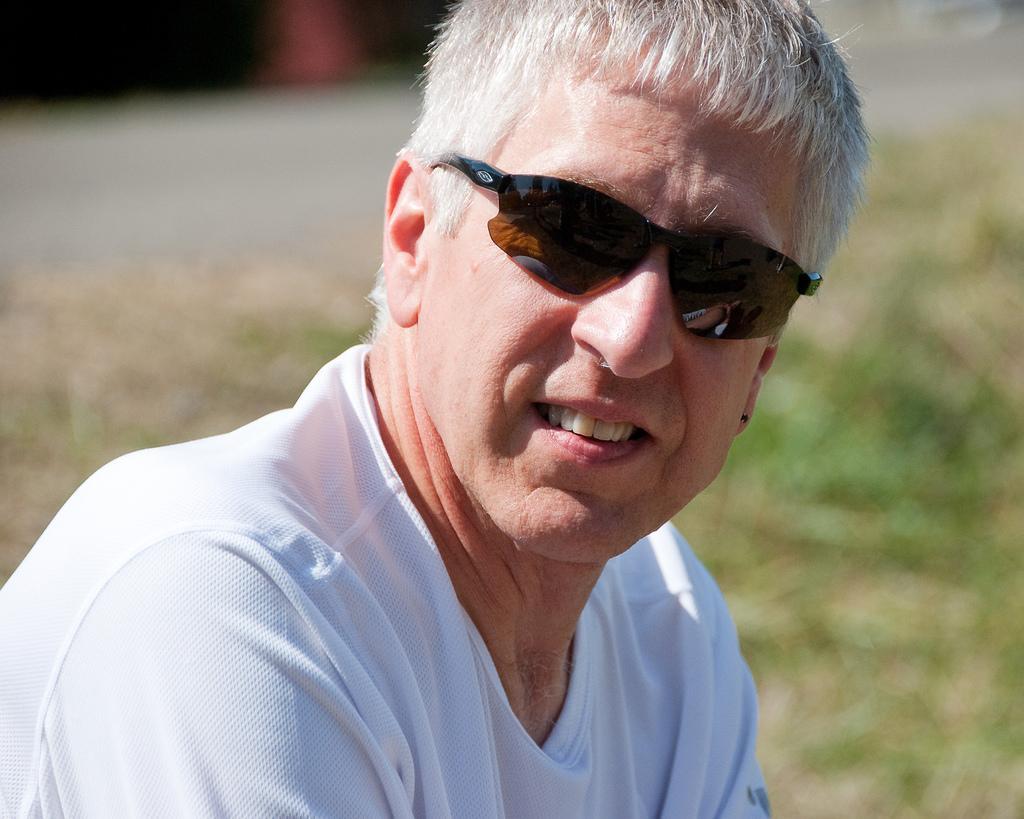Could you give a brief overview of what you see in this image? In this image we can see a man and grass in the background. 